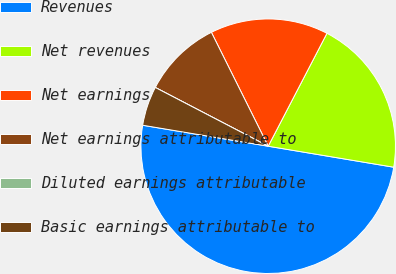<chart> <loc_0><loc_0><loc_500><loc_500><pie_chart><fcel>Revenues<fcel>Net revenues<fcel>Net earnings<fcel>Net earnings attributable to<fcel>Diluted earnings attributable<fcel>Basic earnings attributable to<nl><fcel>50.0%<fcel>20.0%<fcel>15.0%<fcel>10.0%<fcel>0.0%<fcel>5.0%<nl></chart> 